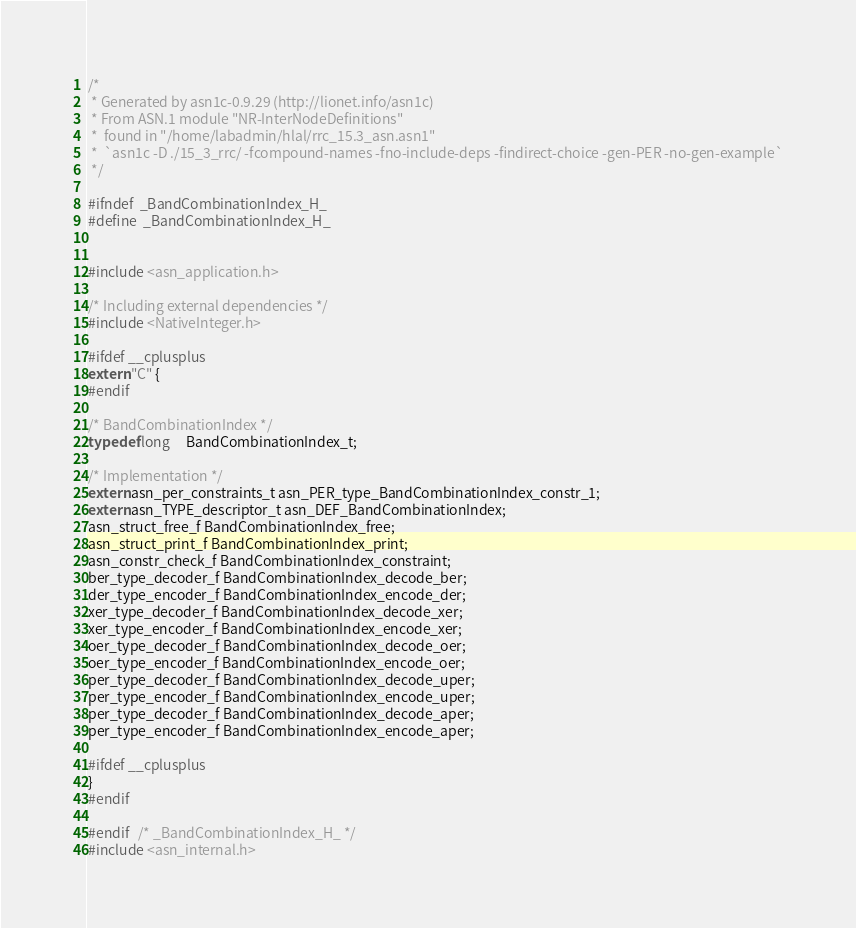Convert code to text. <code><loc_0><loc_0><loc_500><loc_500><_C_>/*
 * Generated by asn1c-0.9.29 (http://lionet.info/asn1c)
 * From ASN.1 module "NR-InterNodeDefinitions"
 * 	found in "/home/labadmin/hlal/rrc_15.3_asn.asn1"
 * 	`asn1c -D ./15_3_rrc/ -fcompound-names -fno-include-deps -findirect-choice -gen-PER -no-gen-example`
 */

#ifndef	_BandCombinationIndex_H_
#define	_BandCombinationIndex_H_


#include <asn_application.h>

/* Including external dependencies */
#include <NativeInteger.h>

#ifdef __cplusplus
extern "C" {
#endif

/* BandCombinationIndex */
typedef long	 BandCombinationIndex_t;

/* Implementation */
extern asn_per_constraints_t asn_PER_type_BandCombinationIndex_constr_1;
extern asn_TYPE_descriptor_t asn_DEF_BandCombinationIndex;
asn_struct_free_f BandCombinationIndex_free;
asn_struct_print_f BandCombinationIndex_print;
asn_constr_check_f BandCombinationIndex_constraint;
ber_type_decoder_f BandCombinationIndex_decode_ber;
der_type_encoder_f BandCombinationIndex_encode_der;
xer_type_decoder_f BandCombinationIndex_decode_xer;
xer_type_encoder_f BandCombinationIndex_encode_xer;
oer_type_decoder_f BandCombinationIndex_decode_oer;
oer_type_encoder_f BandCombinationIndex_encode_oer;
per_type_decoder_f BandCombinationIndex_decode_uper;
per_type_encoder_f BandCombinationIndex_encode_uper;
per_type_decoder_f BandCombinationIndex_decode_aper;
per_type_encoder_f BandCombinationIndex_encode_aper;

#ifdef __cplusplus
}
#endif

#endif	/* _BandCombinationIndex_H_ */
#include <asn_internal.h>
</code> 